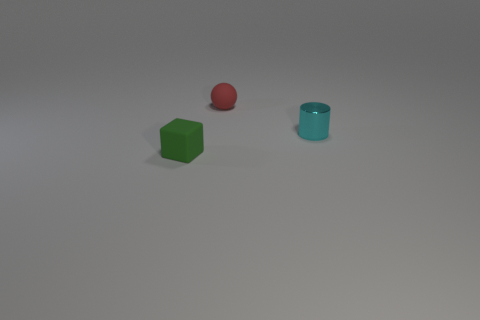Are there any other things that have the same material as the cylinder?
Give a very brief answer. No. Is the color of the tiny object that is on the left side of the small red thing the same as the tiny rubber thing to the right of the rubber block?
Keep it short and to the point. No. What material is the thing that is behind the cylinder in front of the object behind the cyan thing?
Offer a very short reply. Rubber. Are there more red balls than large green metal cylinders?
Your answer should be compact. Yes. Are there any other things that have the same color as the tiny block?
Make the answer very short. No. The green thing that is the same material as the ball is what size?
Your answer should be very brief. Small. What material is the cyan cylinder?
Give a very brief answer. Metal. How many cylinders are the same size as the cyan thing?
Provide a short and direct response. 0. Are there any small rubber objects that have the same shape as the small cyan metal object?
Give a very brief answer. No. The metallic object that is the same size as the green matte block is what color?
Offer a terse response. Cyan. 